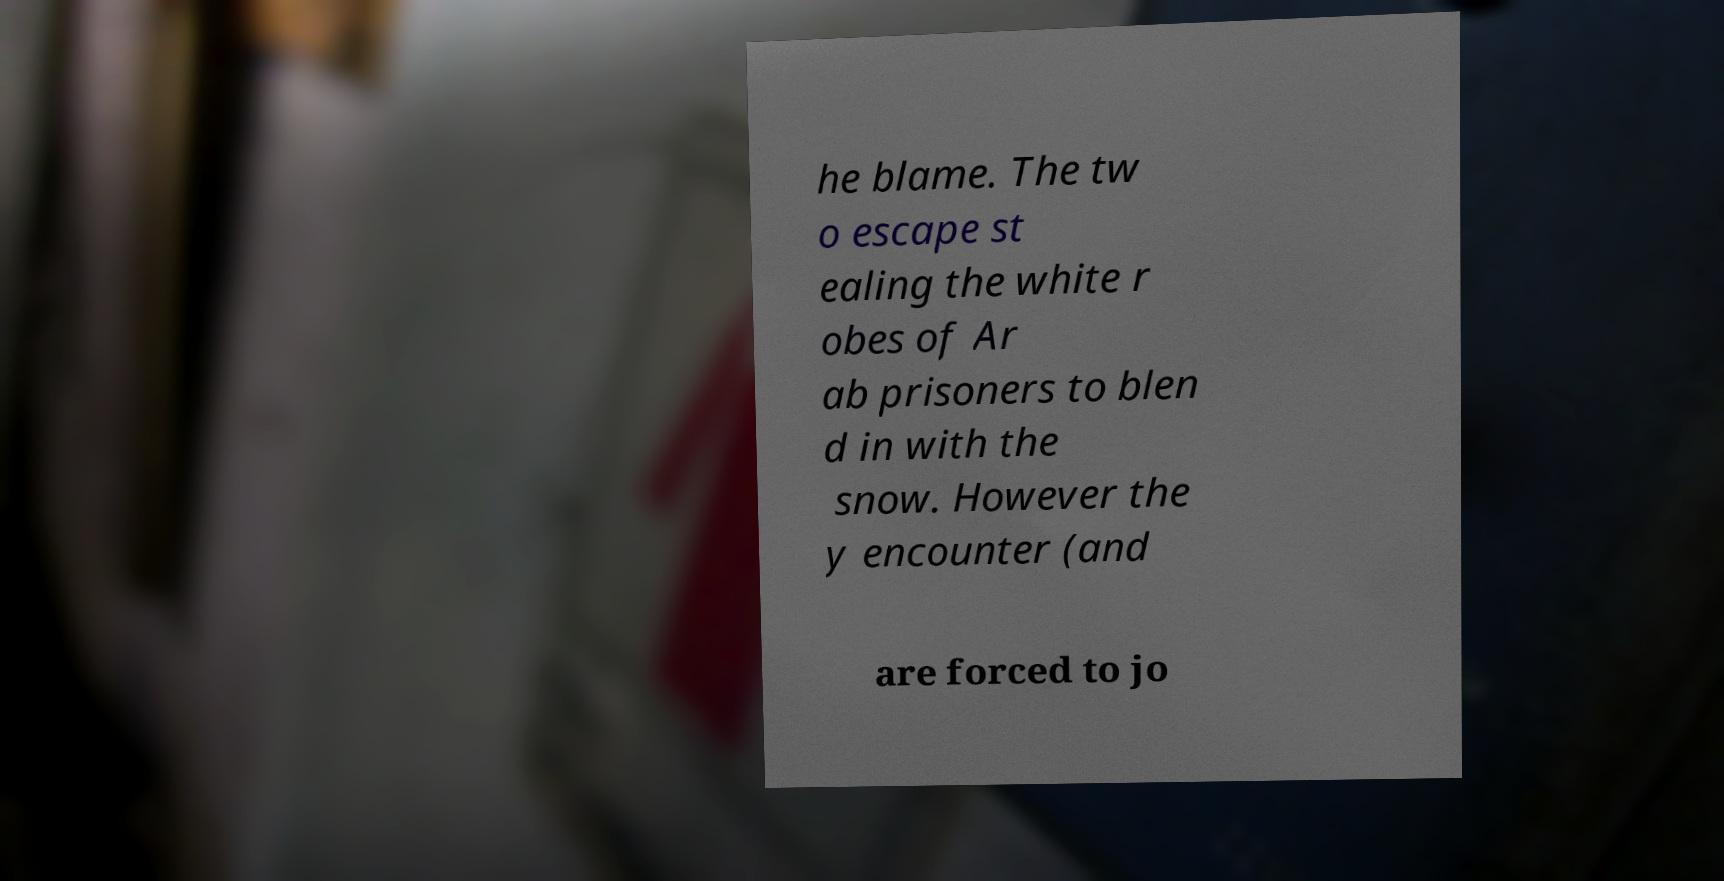I need the written content from this picture converted into text. Can you do that? he blame. The tw o escape st ealing the white r obes of Ar ab prisoners to blen d in with the snow. However the y encounter (and are forced to jo 